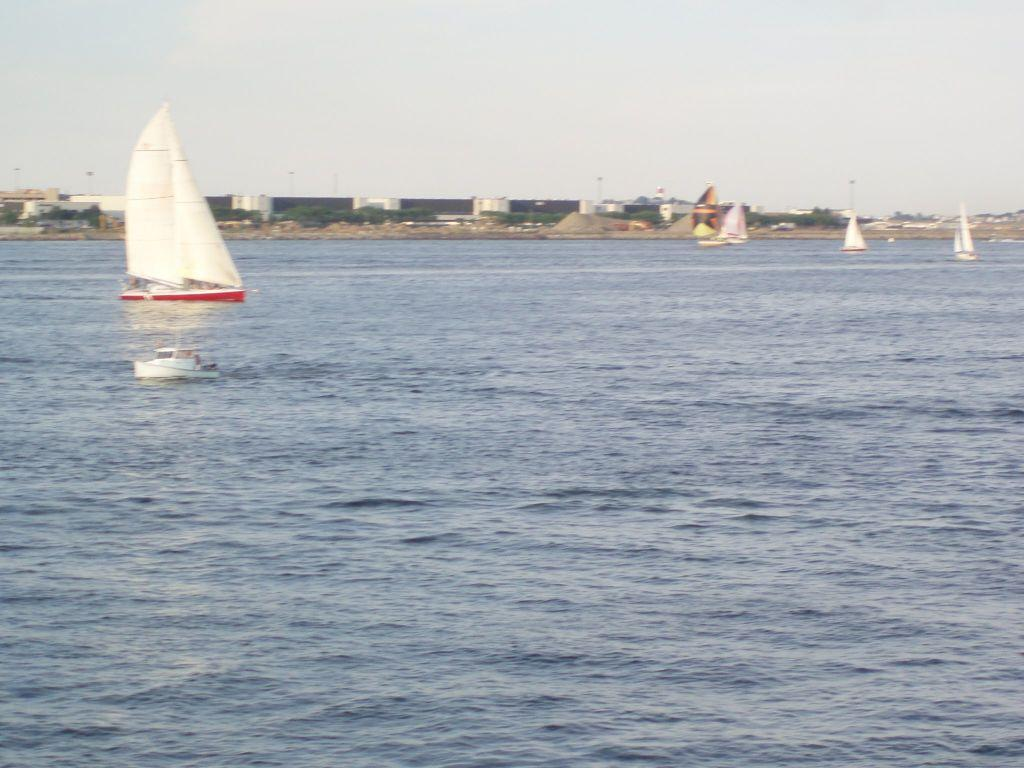What is in the water in the image? There are boats in the water in the image. What can be seen in the background of the image? There is a building and the sky visible in the background of the image. What book is the army reading in the image? There is no army or book present in the image; it features boats in the water and a building in the background. 